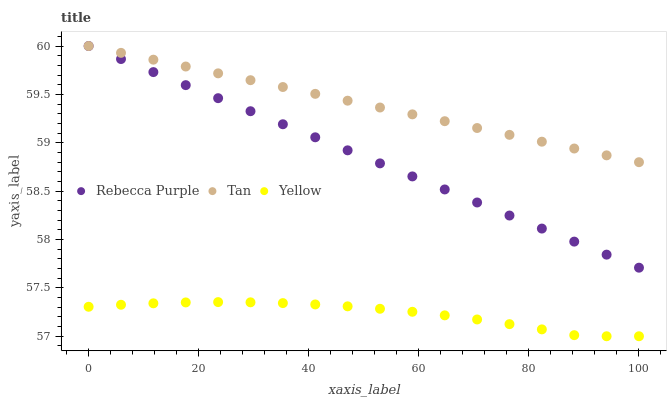Does Yellow have the minimum area under the curve?
Answer yes or no. Yes. Does Tan have the maximum area under the curve?
Answer yes or no. Yes. Does Rebecca Purple have the minimum area under the curve?
Answer yes or no. No. Does Rebecca Purple have the maximum area under the curve?
Answer yes or no. No. Is Rebecca Purple the smoothest?
Answer yes or no. Yes. Is Yellow the roughest?
Answer yes or no. Yes. Is Yellow the smoothest?
Answer yes or no. No. Is Rebecca Purple the roughest?
Answer yes or no. No. Does Yellow have the lowest value?
Answer yes or no. Yes. Does Rebecca Purple have the lowest value?
Answer yes or no. No. Does Rebecca Purple have the highest value?
Answer yes or no. Yes. Does Yellow have the highest value?
Answer yes or no. No. Is Yellow less than Tan?
Answer yes or no. Yes. Is Tan greater than Yellow?
Answer yes or no. Yes. Does Rebecca Purple intersect Tan?
Answer yes or no. Yes. Is Rebecca Purple less than Tan?
Answer yes or no. No. Is Rebecca Purple greater than Tan?
Answer yes or no. No. Does Yellow intersect Tan?
Answer yes or no. No. 